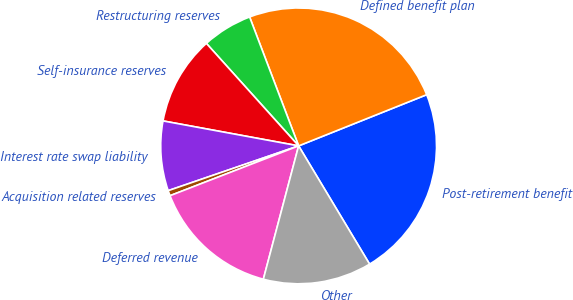Convert chart. <chart><loc_0><loc_0><loc_500><loc_500><pie_chart><fcel>Post-retirement benefit<fcel>Defined benefit plan<fcel>Restructuring reserves<fcel>Self-insurance reserves<fcel>Interest rate swap liability<fcel>Acquisition related reserves<fcel>Deferred revenue<fcel>Other<nl><fcel>22.45%<fcel>24.73%<fcel>5.88%<fcel>10.44%<fcel>8.16%<fcel>0.62%<fcel>15.0%<fcel>12.72%<nl></chart> 